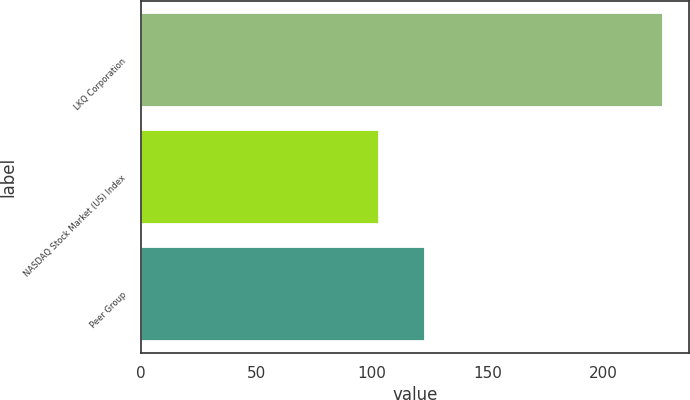Convert chart to OTSL. <chart><loc_0><loc_0><loc_500><loc_500><bar_chart><fcel>LKQ Corporation<fcel>NASDAQ Stock Market (US) Index<fcel>Peer Group<nl><fcel>226<fcel>103<fcel>123<nl></chart> 